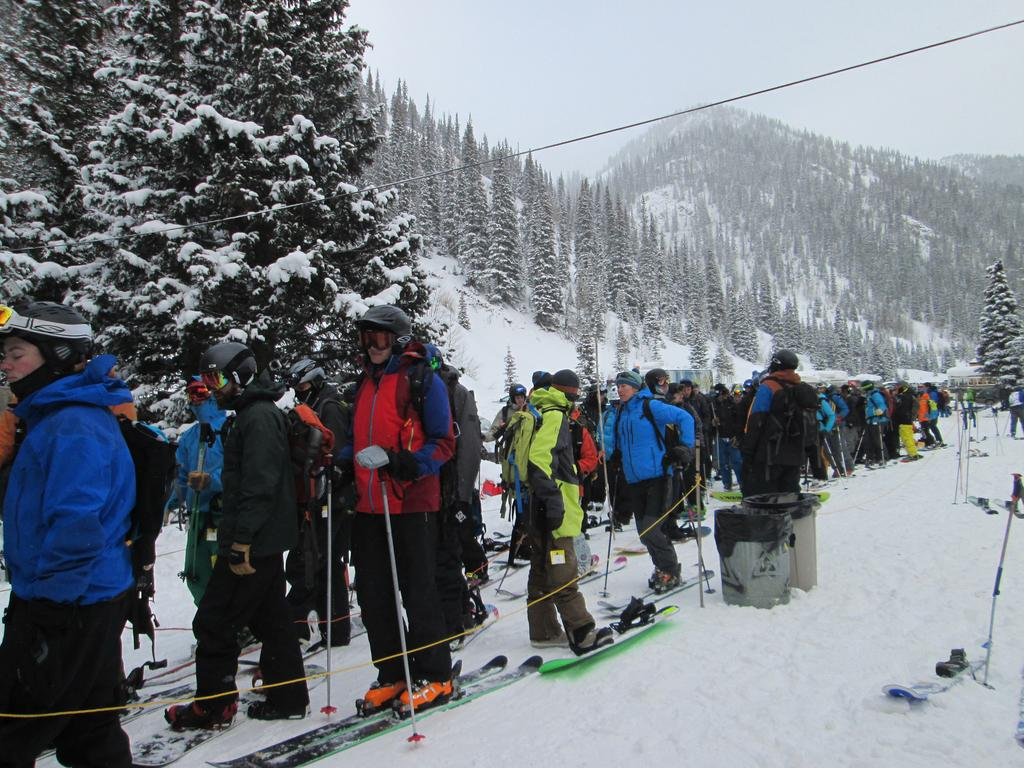What is happening in the image? There is a group of people in the image, and they are standing on ski boards. Where are the people in the image? The people are on snow in the image. What can be seen in the background of the image? There are trees in the background of the image, and they are covered with snow. What is the color of the sky in the image? The sky is white in color in the image. What type of trousers are the people wearing in the image? The provided facts do not mention the type of trousers the people are wearing in the image. Where is the lunchroom located in the image? There is no mention of a lunchroom in the image; it features a group of people on ski boards in a snowy environment. 